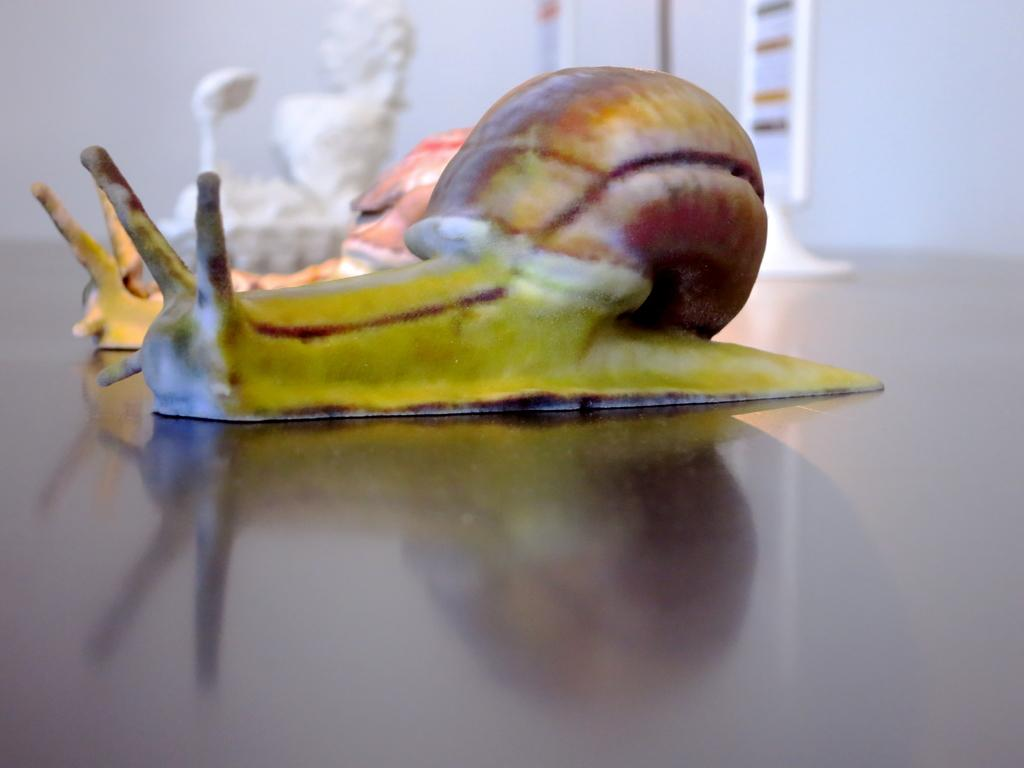What creatures are in the foreground of the image? There are two sea snails in the foreground of the image. Where are the sea snails located? The sea snails are on the floor. What can be seen in the background of the image? There is a sculpture and a wall in the background of the image. In what type of setting is the image taken? The image is taken in a hall. What type of drink is being served to the person in the image? There is no person or drink present in the image; it features two sea snails on the floor and a background with a sculpture and a wall. 